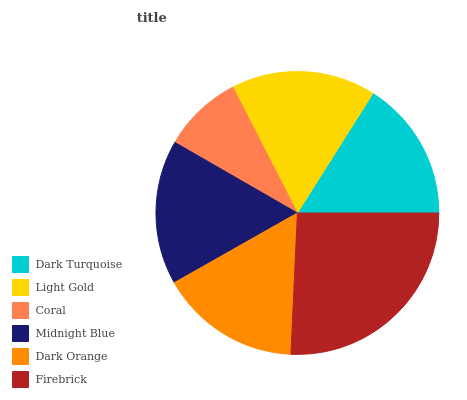Is Coral the minimum?
Answer yes or no. Yes. Is Firebrick the maximum?
Answer yes or no. Yes. Is Light Gold the minimum?
Answer yes or no. No. Is Light Gold the maximum?
Answer yes or no. No. Is Light Gold greater than Dark Turquoise?
Answer yes or no. Yes. Is Dark Turquoise less than Light Gold?
Answer yes or no. Yes. Is Dark Turquoise greater than Light Gold?
Answer yes or no. No. Is Light Gold less than Dark Turquoise?
Answer yes or no. No. Is Light Gold the high median?
Answer yes or no. Yes. Is Dark Orange the low median?
Answer yes or no. Yes. Is Firebrick the high median?
Answer yes or no. No. Is Light Gold the low median?
Answer yes or no. No. 